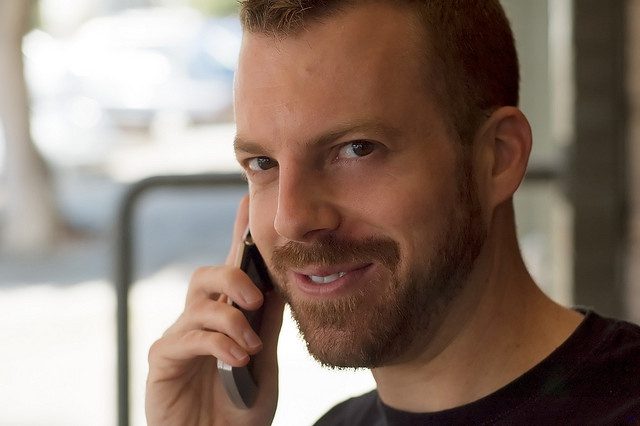Describe the objects in this image and their specific colors. I can see people in darkgray, black, maroon, and brown tones and cell phone in darkgray, black, tan, and maroon tones in this image. 